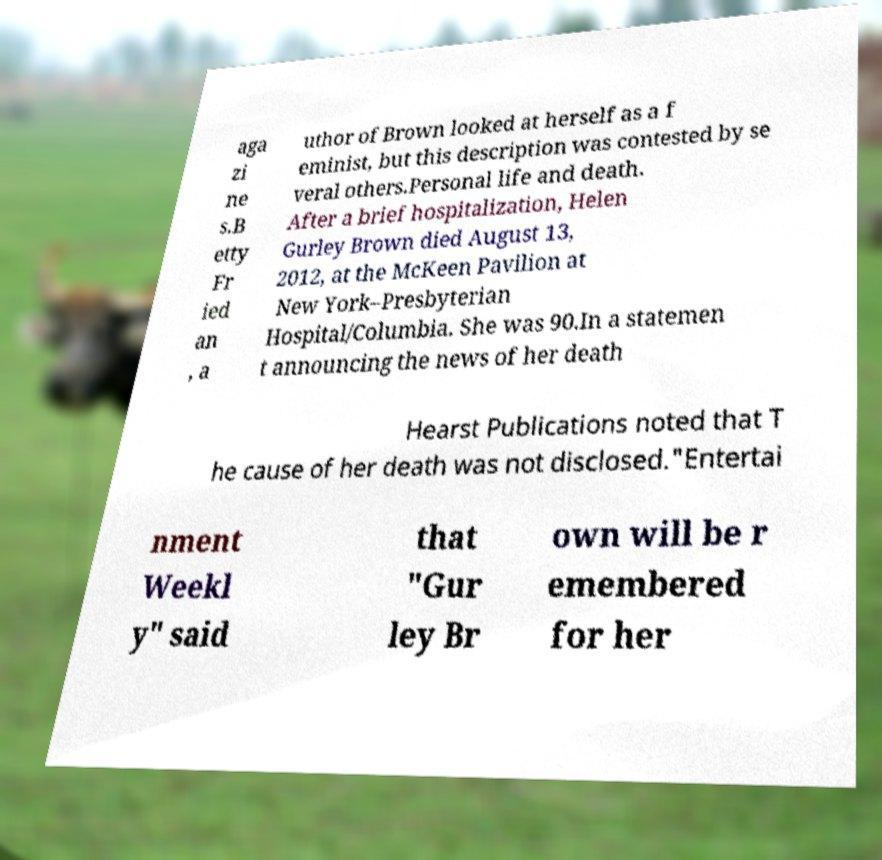Could you assist in decoding the text presented in this image and type it out clearly? aga zi ne s.B etty Fr ied an , a uthor of Brown looked at herself as a f eminist, but this description was contested by se veral others.Personal life and death. After a brief hospitalization, Helen Gurley Brown died August 13, 2012, at the McKeen Pavilion at New York–Presbyterian Hospital/Columbia. She was 90.In a statemen t announcing the news of her death Hearst Publications noted that T he cause of her death was not disclosed."Entertai nment Weekl y" said that "Gur ley Br own will be r emembered for her 